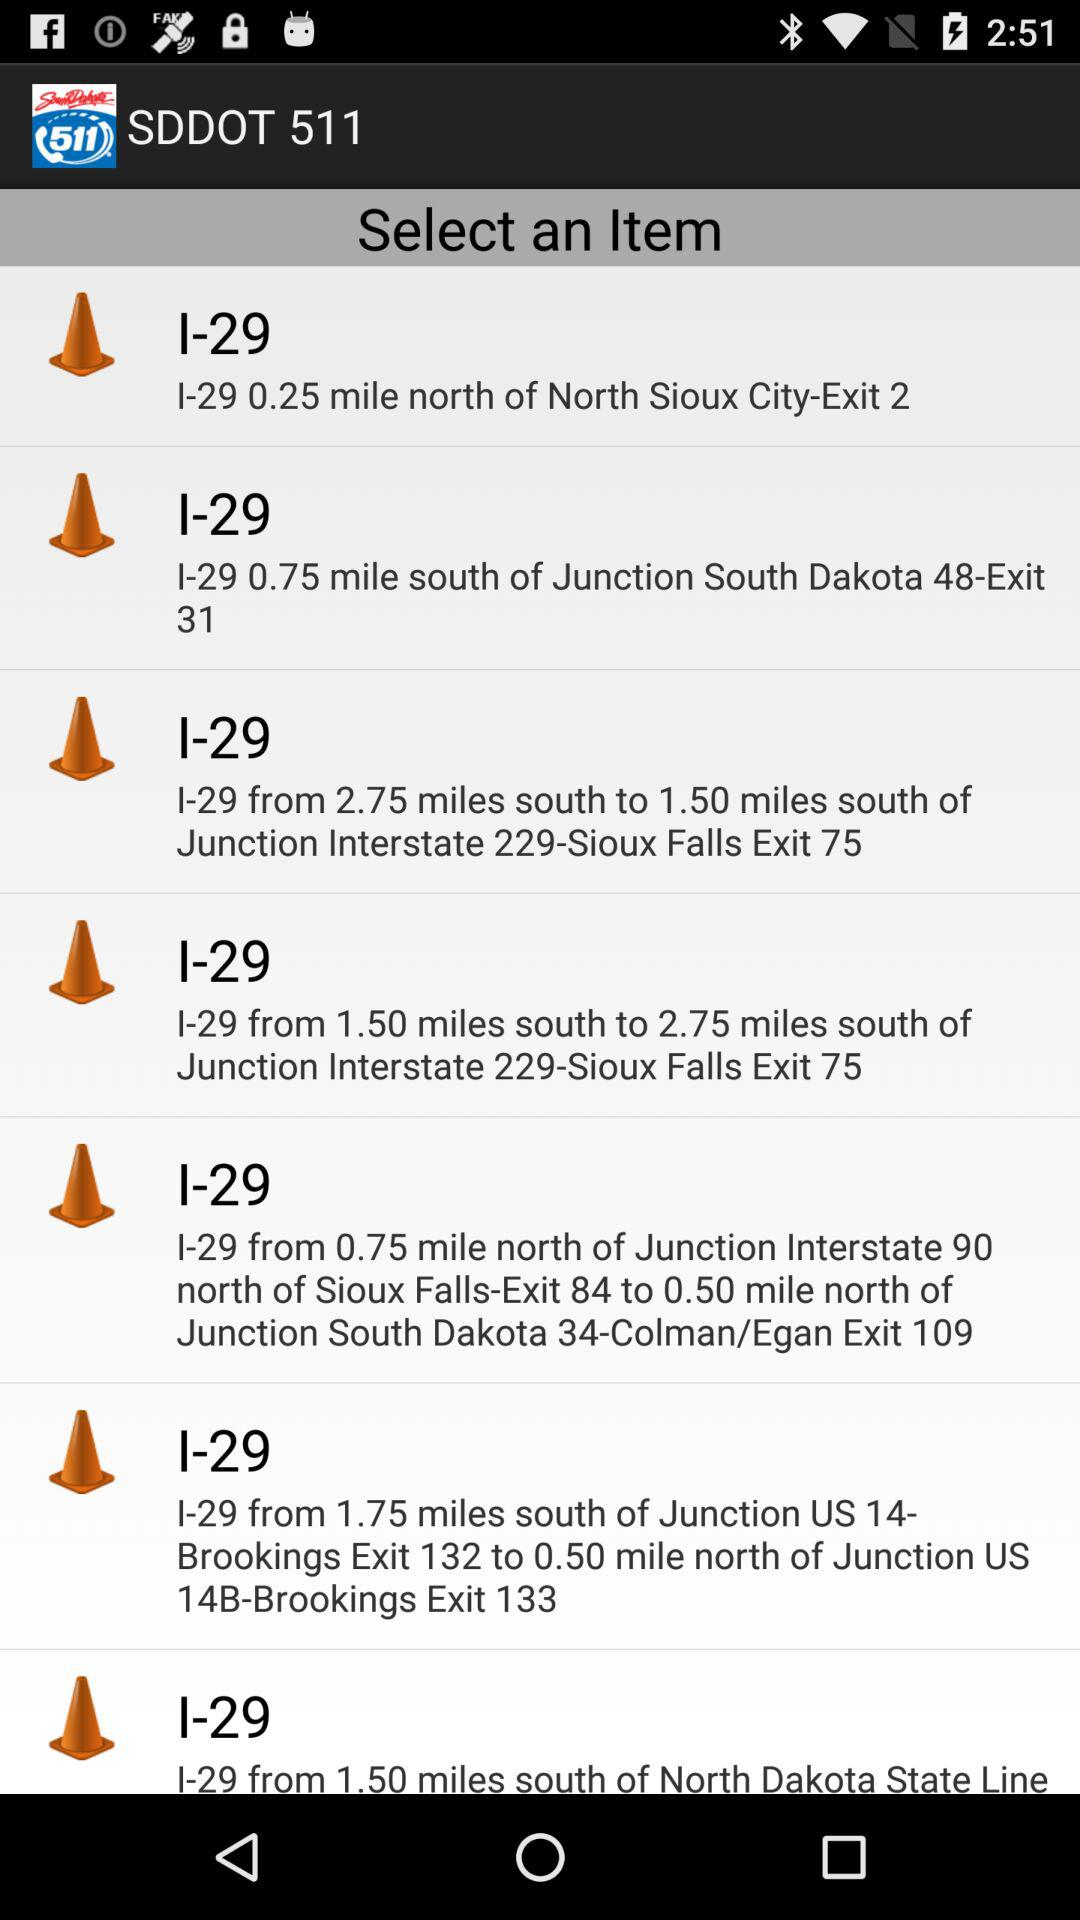I-29 is how many miles from north of junction interstate 90 north of sioux falls exit 84? I-29 is 0.75 miles from the north of connector interstate 90 north of the Sioux Falls exit 84. 